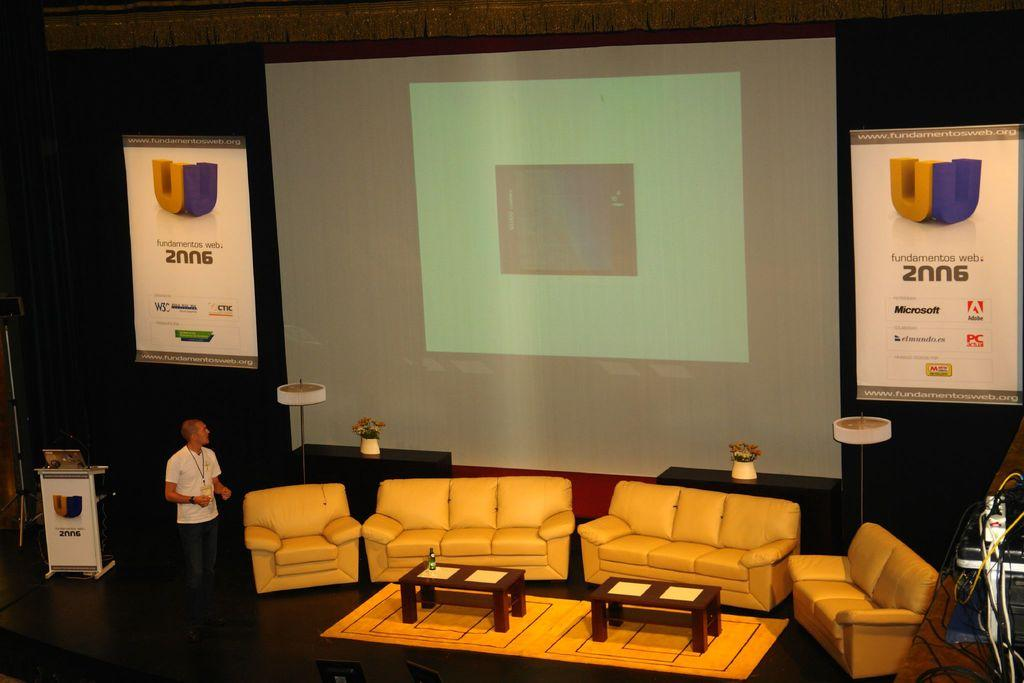What is the main subject of the image? There is a man standing in the image. Where is the man standing? The man is standing on the floor. What is the large, flat object in the image? There is a projector screen in the image. What type of furniture is present on the floor in the image? There are couches and tables on the floor in the image. What type of tax is being discussed in the image? There is no discussion of tax in the image; it features a man standing, a projector screen, couches, and tables. What color is the man's stocking in the image? There is no mention of stockings in the image, and the man's clothing is not described. 